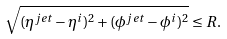Convert formula to latex. <formula><loc_0><loc_0><loc_500><loc_500>\sqrt { ( \eta ^ { j e t } - \eta ^ { i } ) ^ { 2 } + ( \phi ^ { j e t } - \phi ^ { i } ) ^ { 2 } } \leq R .</formula> 